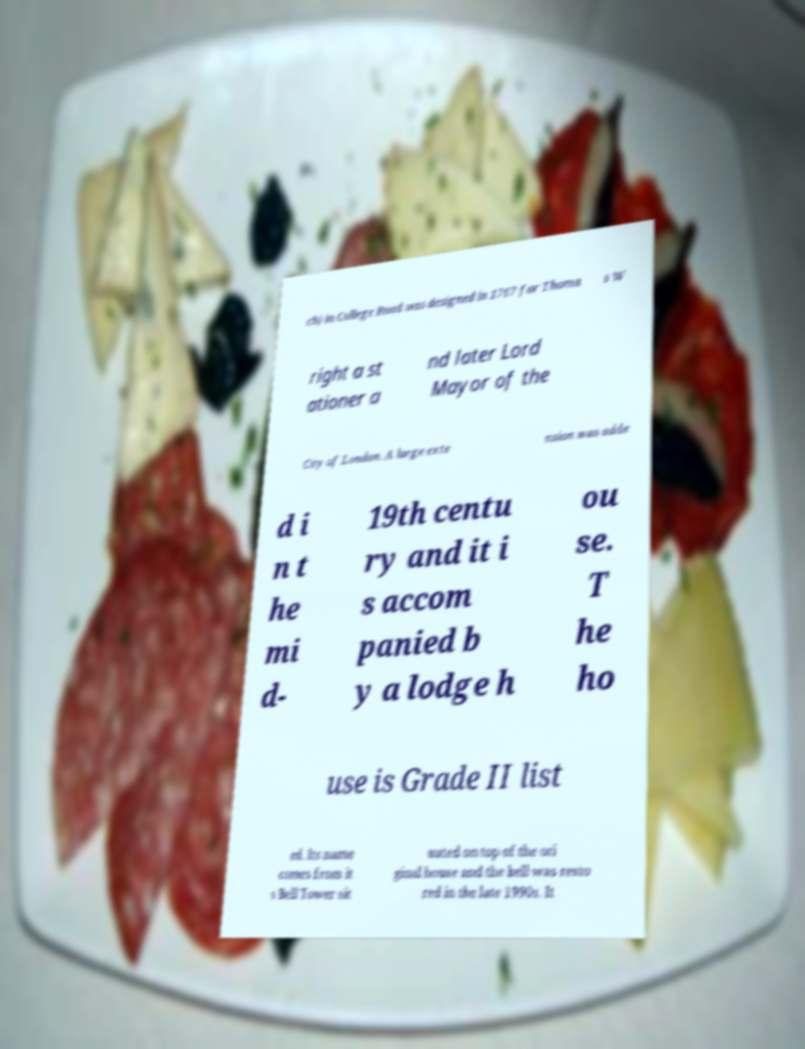Can you read and provide the text displayed in the image?This photo seems to have some interesting text. Can you extract and type it out for me? ch) in College Road was designed in 1767 for Thoma s W right a st ationer a nd later Lord Mayor of the City of London. A large exte nsion was adde d i n t he mi d- 19th centu ry and it i s accom panied b y a lodge h ou se. T he ho use is Grade II list ed. Its name comes from it s Bell Tower sit uated on top of the ori ginal house and the bell was resto red in the late 1990s. It 